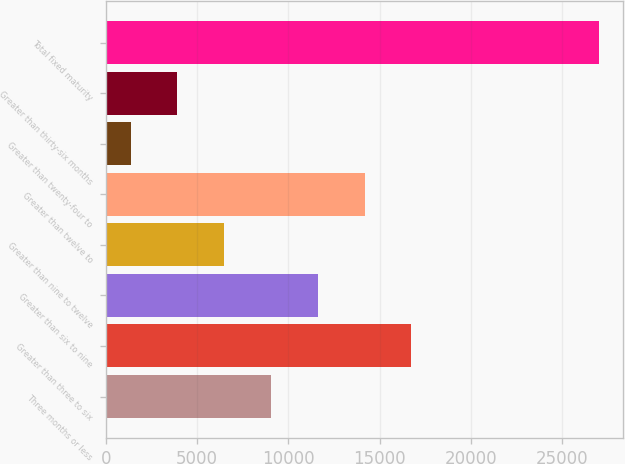Convert chart to OTSL. <chart><loc_0><loc_0><loc_500><loc_500><bar_chart><fcel>Three months or less<fcel>Greater than three to six<fcel>Greater than six to nine<fcel>Greater than nine to twelve<fcel>Greater than twelve to<fcel>Greater than twenty-four to<fcel>Greater than thirty-six months<fcel>Total fixed maturity<nl><fcel>9050.84<fcel>16744<fcel>11615.2<fcel>6486.46<fcel>14179.6<fcel>1357.7<fcel>3922.08<fcel>27001.5<nl></chart> 